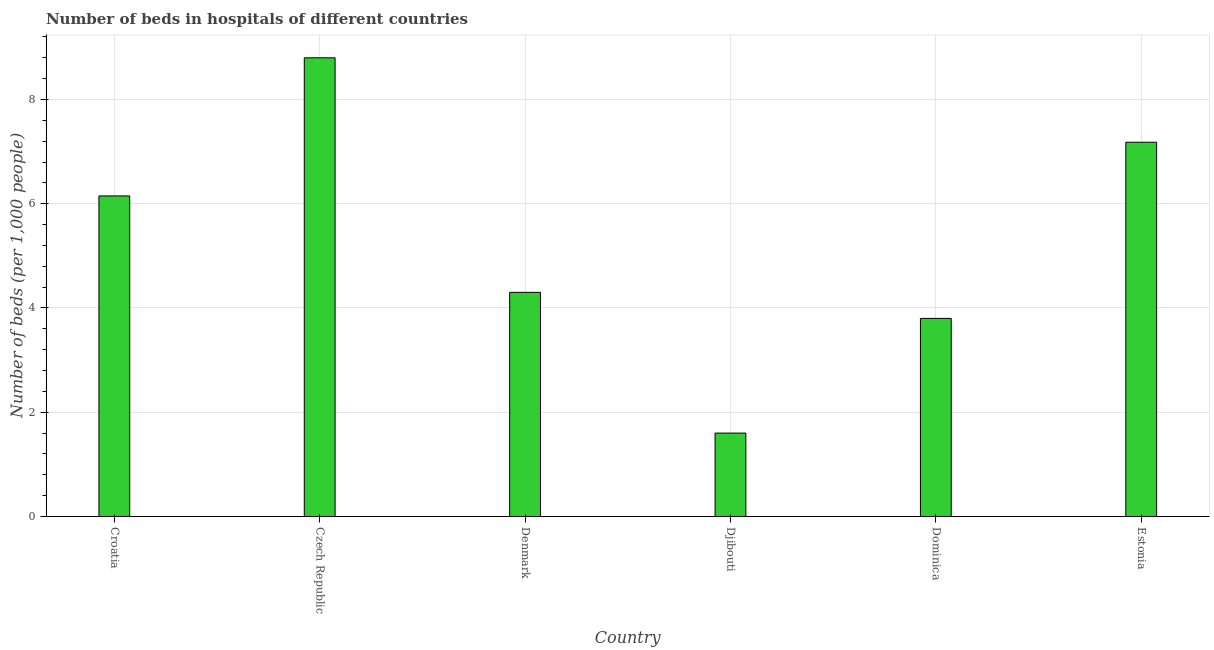Does the graph contain any zero values?
Give a very brief answer. No. Does the graph contain grids?
Offer a terse response. Yes. What is the title of the graph?
Offer a terse response. Number of beds in hospitals of different countries. What is the label or title of the X-axis?
Provide a short and direct response. Country. What is the label or title of the Y-axis?
Give a very brief answer. Number of beds (per 1,0 people). Across all countries, what is the maximum number of hospital beds?
Give a very brief answer. 8.8. Across all countries, what is the minimum number of hospital beds?
Offer a terse response. 1.6. In which country was the number of hospital beds maximum?
Make the answer very short. Czech Republic. In which country was the number of hospital beds minimum?
Offer a very short reply. Djibouti. What is the sum of the number of hospital beds?
Offer a terse response. 31.83. What is the difference between the number of hospital beds in Croatia and Denmark?
Your response must be concise. 1.85. What is the average number of hospital beds per country?
Provide a succinct answer. 5.3. What is the median number of hospital beds?
Ensure brevity in your answer.  5.23. What is the ratio of the number of hospital beds in Croatia to that in Estonia?
Your answer should be very brief. 0.86. Is the number of hospital beds in Croatia less than that in Denmark?
Ensure brevity in your answer.  No. Is the difference between the number of hospital beds in Croatia and Denmark greater than the difference between any two countries?
Provide a succinct answer. No. What is the difference between the highest and the second highest number of hospital beds?
Keep it short and to the point. 1.62. What is the difference between the highest and the lowest number of hospital beds?
Your answer should be very brief. 7.2. In how many countries, is the number of hospital beds greater than the average number of hospital beds taken over all countries?
Make the answer very short. 3. Are all the bars in the graph horizontal?
Offer a very short reply. No. How many countries are there in the graph?
Keep it short and to the point. 6. What is the difference between two consecutive major ticks on the Y-axis?
Your answer should be very brief. 2. Are the values on the major ticks of Y-axis written in scientific E-notation?
Make the answer very short. No. What is the Number of beds (per 1,000 people) of Croatia?
Make the answer very short. 6.15. What is the Number of beds (per 1,000 people) of Czech Republic?
Your answer should be very brief. 8.8. What is the Number of beds (per 1,000 people) of Denmark?
Make the answer very short. 4.3. What is the Number of beds (per 1,000 people) in Djibouti?
Your response must be concise. 1.6. What is the Number of beds (per 1,000 people) in Dominica?
Your answer should be very brief. 3.8. What is the Number of beds (per 1,000 people) of Estonia?
Keep it short and to the point. 7.18. What is the difference between the Number of beds (per 1,000 people) in Croatia and Czech Republic?
Make the answer very short. -2.65. What is the difference between the Number of beds (per 1,000 people) in Croatia and Denmark?
Offer a very short reply. 1.85. What is the difference between the Number of beds (per 1,000 people) in Croatia and Djibouti?
Give a very brief answer. 4.55. What is the difference between the Number of beds (per 1,000 people) in Croatia and Dominica?
Make the answer very short. 2.35. What is the difference between the Number of beds (per 1,000 people) in Croatia and Estonia?
Your answer should be compact. -1.03. What is the difference between the Number of beds (per 1,000 people) in Czech Republic and Denmark?
Give a very brief answer. 4.5. What is the difference between the Number of beds (per 1,000 people) in Czech Republic and Djibouti?
Keep it short and to the point. 7.2. What is the difference between the Number of beds (per 1,000 people) in Czech Republic and Dominica?
Your answer should be compact. 5. What is the difference between the Number of beds (per 1,000 people) in Czech Republic and Estonia?
Ensure brevity in your answer.  1.62. What is the difference between the Number of beds (per 1,000 people) in Denmark and Dominica?
Your response must be concise. 0.5. What is the difference between the Number of beds (per 1,000 people) in Denmark and Estonia?
Your response must be concise. -2.88. What is the difference between the Number of beds (per 1,000 people) in Djibouti and Dominica?
Ensure brevity in your answer.  -2.2. What is the difference between the Number of beds (per 1,000 people) in Djibouti and Estonia?
Your response must be concise. -5.58. What is the difference between the Number of beds (per 1,000 people) in Dominica and Estonia?
Give a very brief answer. -3.38. What is the ratio of the Number of beds (per 1,000 people) in Croatia to that in Czech Republic?
Provide a short and direct response. 0.7. What is the ratio of the Number of beds (per 1,000 people) in Croatia to that in Denmark?
Your response must be concise. 1.43. What is the ratio of the Number of beds (per 1,000 people) in Croatia to that in Djibouti?
Provide a short and direct response. 3.84. What is the ratio of the Number of beds (per 1,000 people) in Croatia to that in Dominica?
Offer a very short reply. 1.62. What is the ratio of the Number of beds (per 1,000 people) in Croatia to that in Estonia?
Your answer should be very brief. 0.86. What is the ratio of the Number of beds (per 1,000 people) in Czech Republic to that in Denmark?
Your answer should be very brief. 2.05. What is the ratio of the Number of beds (per 1,000 people) in Czech Republic to that in Djibouti?
Keep it short and to the point. 5.5. What is the ratio of the Number of beds (per 1,000 people) in Czech Republic to that in Dominica?
Keep it short and to the point. 2.32. What is the ratio of the Number of beds (per 1,000 people) in Czech Republic to that in Estonia?
Give a very brief answer. 1.23. What is the ratio of the Number of beds (per 1,000 people) in Denmark to that in Djibouti?
Provide a short and direct response. 2.69. What is the ratio of the Number of beds (per 1,000 people) in Denmark to that in Dominica?
Your answer should be compact. 1.13. What is the ratio of the Number of beds (per 1,000 people) in Denmark to that in Estonia?
Provide a short and direct response. 0.6. What is the ratio of the Number of beds (per 1,000 people) in Djibouti to that in Dominica?
Offer a very short reply. 0.42. What is the ratio of the Number of beds (per 1,000 people) in Djibouti to that in Estonia?
Give a very brief answer. 0.22. What is the ratio of the Number of beds (per 1,000 people) in Dominica to that in Estonia?
Provide a short and direct response. 0.53. 